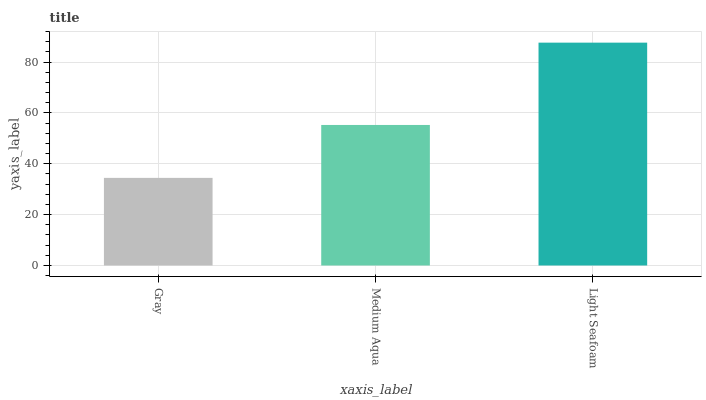Is Gray the minimum?
Answer yes or no. Yes. Is Light Seafoam the maximum?
Answer yes or no. Yes. Is Medium Aqua the minimum?
Answer yes or no. No. Is Medium Aqua the maximum?
Answer yes or no. No. Is Medium Aqua greater than Gray?
Answer yes or no. Yes. Is Gray less than Medium Aqua?
Answer yes or no. Yes. Is Gray greater than Medium Aqua?
Answer yes or no. No. Is Medium Aqua less than Gray?
Answer yes or no. No. Is Medium Aqua the high median?
Answer yes or no. Yes. Is Medium Aqua the low median?
Answer yes or no. Yes. Is Gray the high median?
Answer yes or no. No. Is Gray the low median?
Answer yes or no. No. 